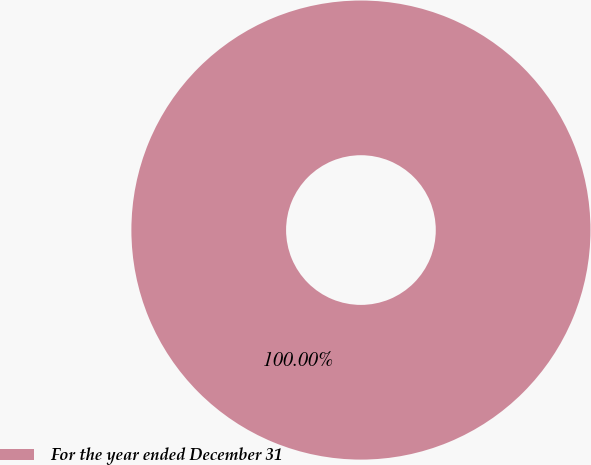Convert chart to OTSL. <chart><loc_0><loc_0><loc_500><loc_500><pie_chart><fcel>For the year ended December 31<nl><fcel>100.0%<nl></chart> 